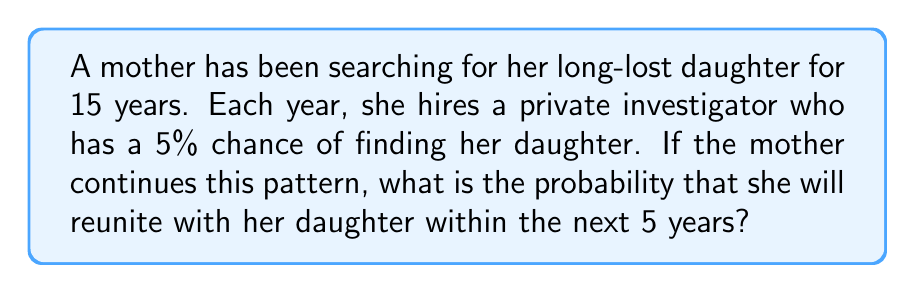Solve this math problem. Let's approach this step-by-step:

1) First, we need to calculate the probability of not finding the daughter in a single year:
   $P(\text{not finding in one year}) = 1 - 0.05 = 0.95$ or 95%

2) To find the daughter within the next 5 years, we need to calculate the probability of not finding her for 5 consecutive years and then subtract that from 1:

   $P(\text{finding within 5 years}) = 1 - P(\text{not finding for 5 years})$

3) The probability of not finding for 5 years is:
   $P(\text{not finding for 5 years}) = 0.95^5$

4) Now we can calculate:
   $$\begin{align}
   P(\text{finding within 5 years}) &= 1 - 0.95^5 \\
   &= 1 - 0.7738 \\
   &\approx 0.2262
   \end{align}$$

5) Convert to a percentage:
   $0.2262 \times 100\% \approx 22.62\%$

Therefore, the probability of the mother reuniting with her daughter within the next 5 years is approximately 22.62%.
Answer: 22.62% 